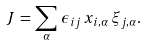<formula> <loc_0><loc_0><loc_500><loc_500>J \, = \, \sum _ { \alpha } \, \epsilon _ { i j } \, x _ { i , \alpha } \, \xi _ { j , \alpha } .</formula> 